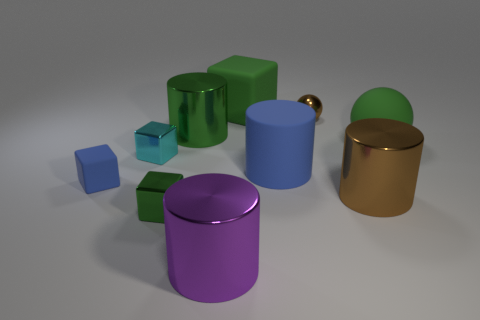Subtract 1 cylinders. How many cylinders are left? 3 Subtract all gray cylinders. Subtract all cyan cubes. How many cylinders are left? 4 Subtract all spheres. How many objects are left? 8 Subtract all purple shiny cylinders. Subtract all metallic spheres. How many objects are left? 8 Add 6 purple metallic objects. How many purple metallic objects are left? 7 Add 3 tiny metal blocks. How many tiny metal blocks exist? 5 Subtract 0 yellow spheres. How many objects are left? 10 